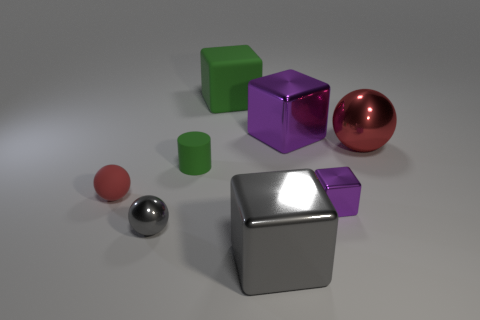How many purple cubes must be subtracted to get 1 purple cubes? 1 Add 1 green blocks. How many objects exist? 9 Subtract all balls. How many objects are left? 5 Subtract all small metal cubes. Subtract all tiny red balls. How many objects are left? 6 Add 5 large rubber blocks. How many large rubber blocks are left? 6 Add 2 large gray objects. How many large gray objects exist? 3 Subtract 0 cyan cylinders. How many objects are left? 8 